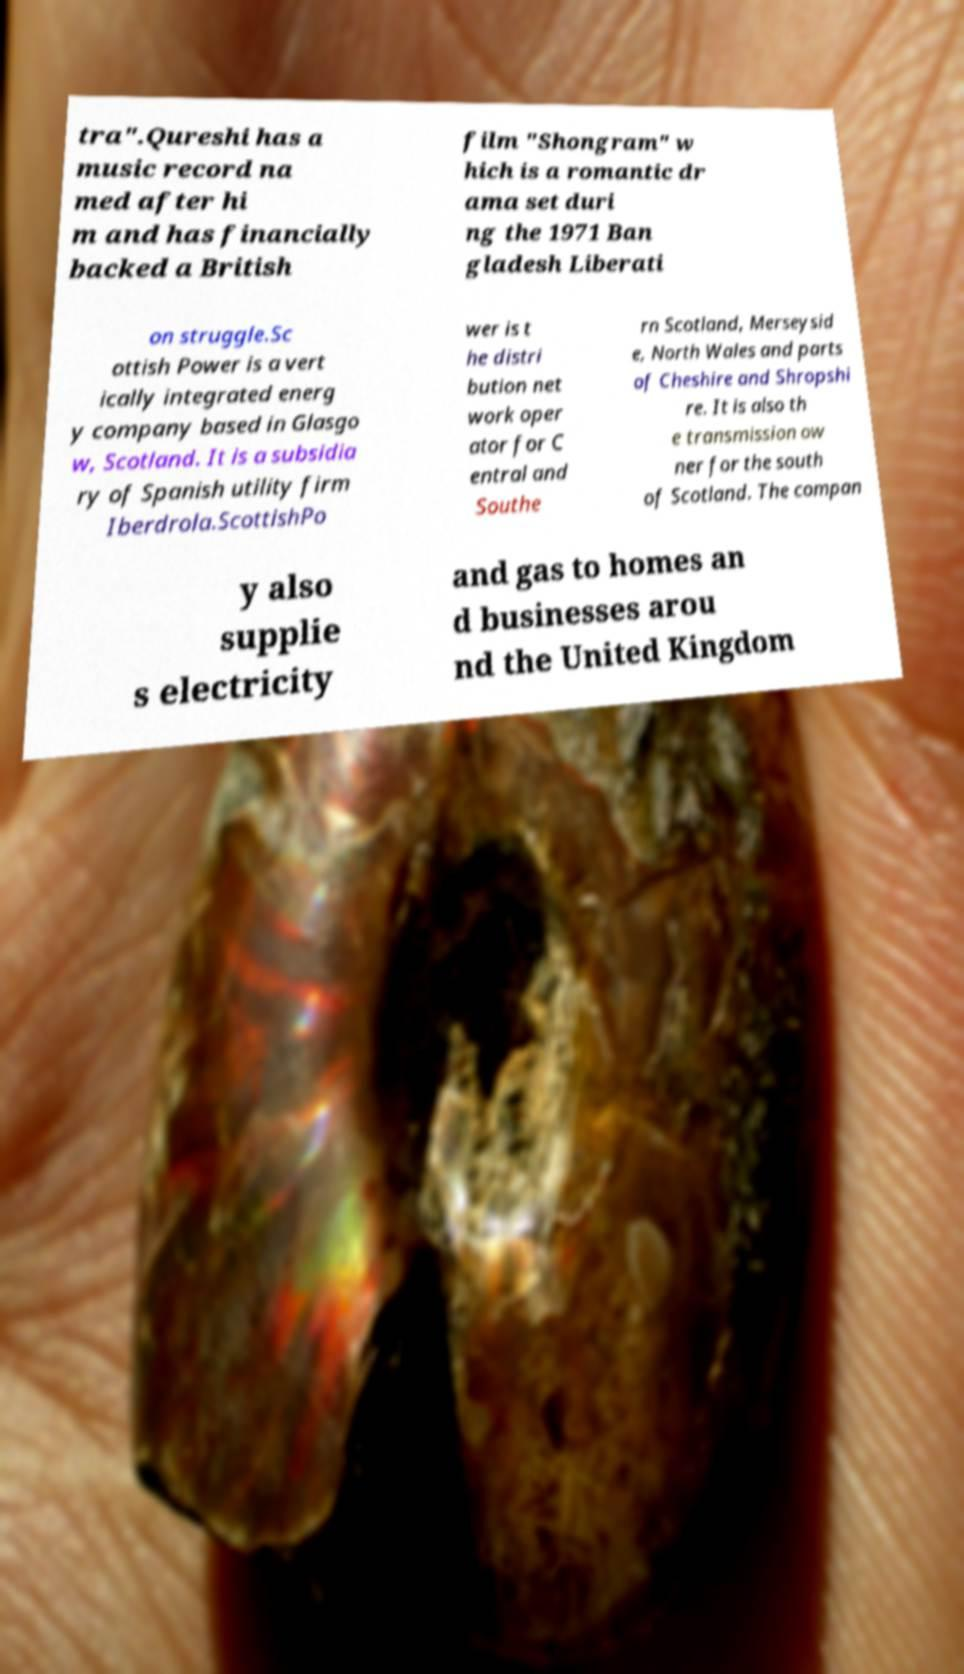Please read and relay the text visible in this image. What does it say? tra".Qureshi has a music record na med after hi m and has financially backed a British film "Shongram" w hich is a romantic dr ama set duri ng the 1971 Ban gladesh Liberati on struggle.Sc ottish Power is a vert ically integrated energ y company based in Glasgo w, Scotland. It is a subsidia ry of Spanish utility firm Iberdrola.ScottishPo wer is t he distri bution net work oper ator for C entral and Southe rn Scotland, Merseysid e, North Wales and parts of Cheshire and Shropshi re. It is also th e transmission ow ner for the south of Scotland. The compan y also supplie s electricity and gas to homes an d businesses arou nd the United Kingdom 